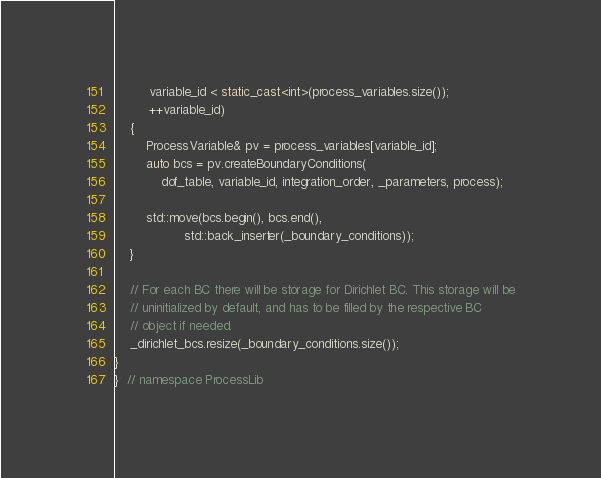Convert code to text. <code><loc_0><loc_0><loc_500><loc_500><_C++_>         variable_id < static_cast<int>(process_variables.size());
         ++variable_id)
    {
        ProcessVariable& pv = process_variables[variable_id];
        auto bcs = pv.createBoundaryConditions(
            dof_table, variable_id, integration_order, _parameters, process);

        std::move(bcs.begin(), bcs.end(),
                  std::back_inserter(_boundary_conditions));
    }

    // For each BC there will be storage for Dirichlet BC. This storage will be
    // uninitialized by default, and has to be filled by the respective BC
    // object if needed.
    _dirichlet_bcs.resize(_boundary_conditions.size());
}
}  // namespace ProcessLib
</code> 